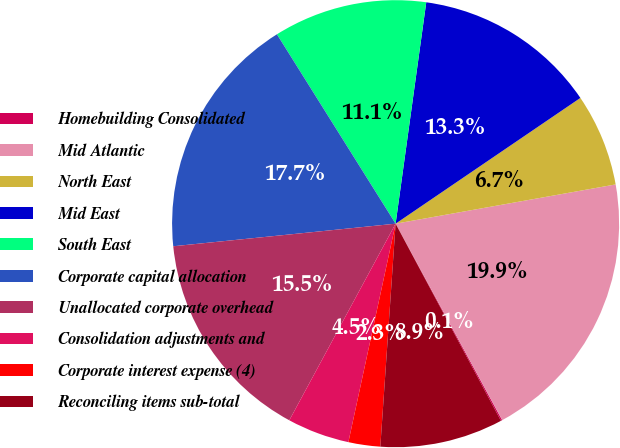<chart> <loc_0><loc_0><loc_500><loc_500><pie_chart><fcel>Homebuilding Consolidated<fcel>Mid Atlantic<fcel>North East<fcel>Mid East<fcel>South East<fcel>Corporate capital allocation<fcel>Unallocated corporate overhead<fcel>Consolidation adjustments and<fcel>Corporate interest expense (4)<fcel>Reconciling items sub-total<nl><fcel>0.1%<fcel>19.9%<fcel>6.7%<fcel>13.3%<fcel>11.1%<fcel>17.7%<fcel>15.5%<fcel>4.5%<fcel>2.3%<fcel>8.9%<nl></chart> 